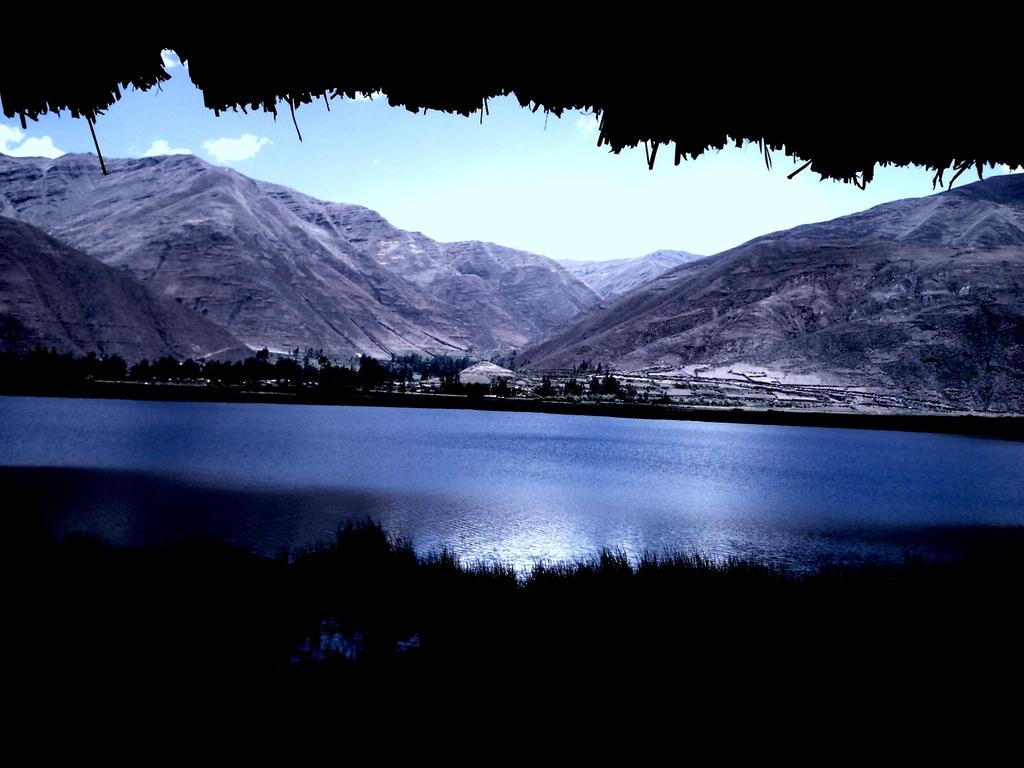What is the primary element visible in the image? There is water in the image. What type of natural features can be seen in the image? There are trees and mountains in the image. What is visible in the sky in the image? There are clouds visible in the sky. What type of coat is hanging on the tree in the image? There is no coat present in the image; it features water, trees, mountains, and clouds. 